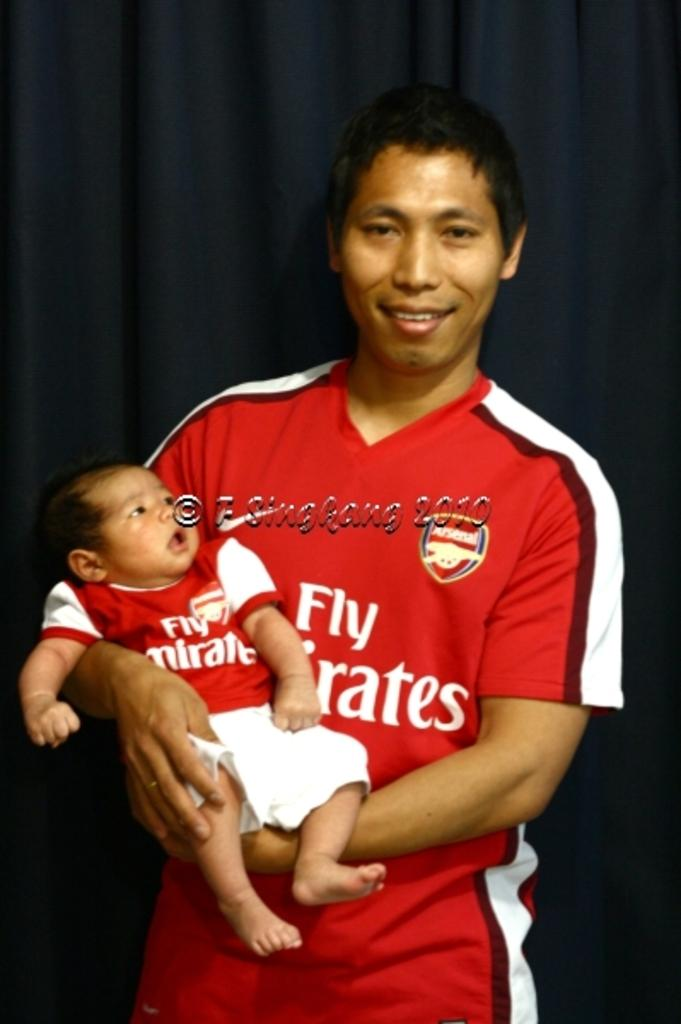Provide a one-sentence caption for the provided image. A man is holding a baby and wearing matching Fly Emirates jerseys. 